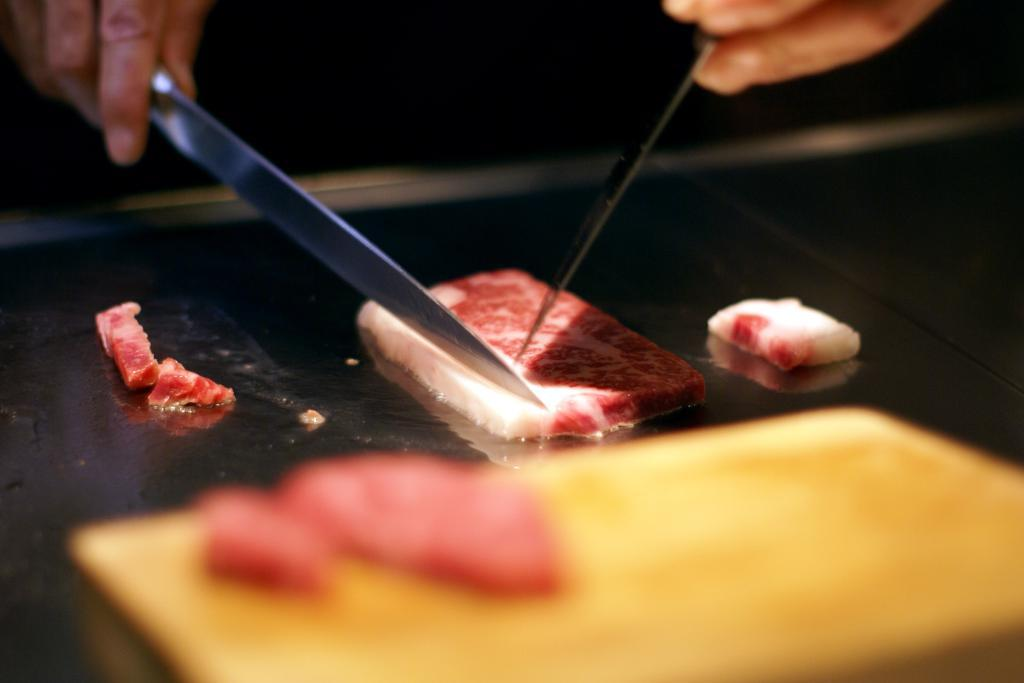What is the main object in the image? There is a piece of bread in the image. What is the color of the surface beneath the bread? The surface beneath the bread is black. How many knives are visible in the image? There are two knives in the image. Who is holding the knives? The knives are being held by human hands. Can you see the ocean in the image? No, the ocean is not present in the image. Is there a spy in the image? No, there is no spy depicted in the image. 